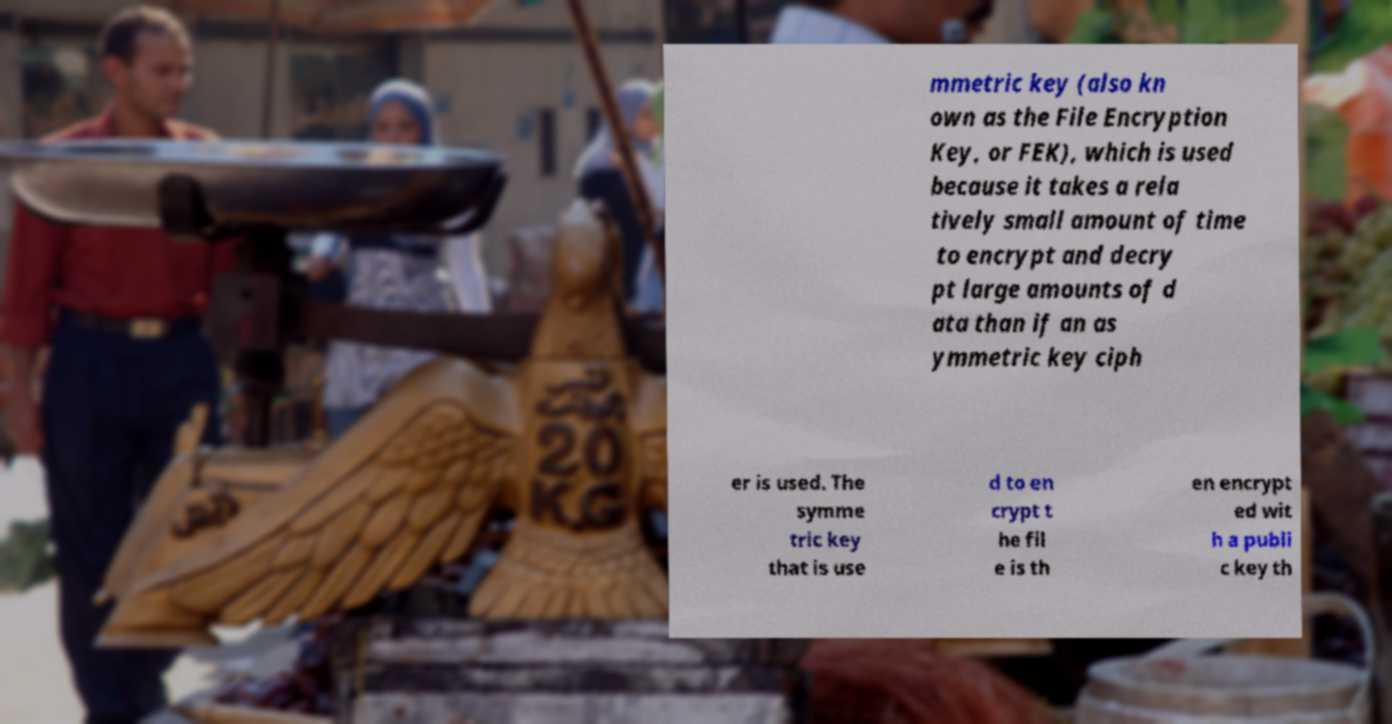Can you accurately transcribe the text from the provided image for me? mmetric key (also kn own as the File Encryption Key, or FEK), which is used because it takes a rela tively small amount of time to encrypt and decry pt large amounts of d ata than if an as ymmetric key ciph er is used. The symme tric key that is use d to en crypt t he fil e is th en encrypt ed wit h a publi c key th 